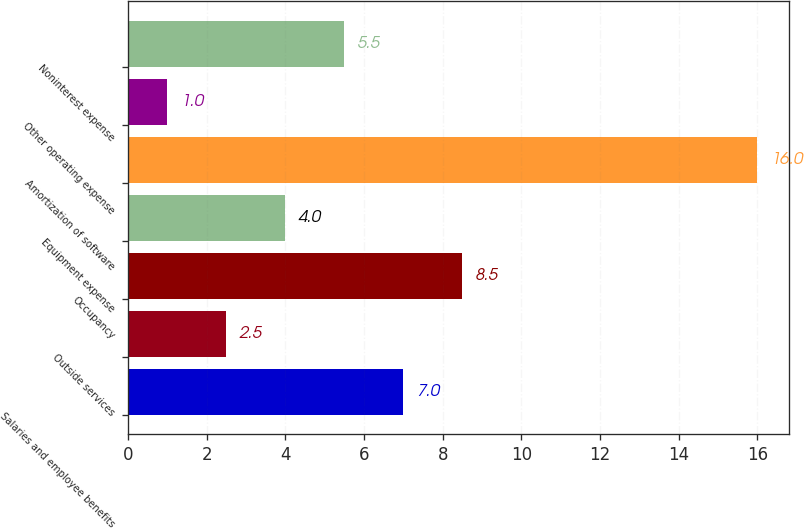<chart> <loc_0><loc_0><loc_500><loc_500><bar_chart><fcel>Salaries and employee benefits<fcel>Outside services<fcel>Occupancy<fcel>Equipment expense<fcel>Amortization of software<fcel>Other operating expense<fcel>Noninterest expense<nl><fcel>7<fcel>2.5<fcel>8.5<fcel>4<fcel>16<fcel>1<fcel>5.5<nl></chart> 